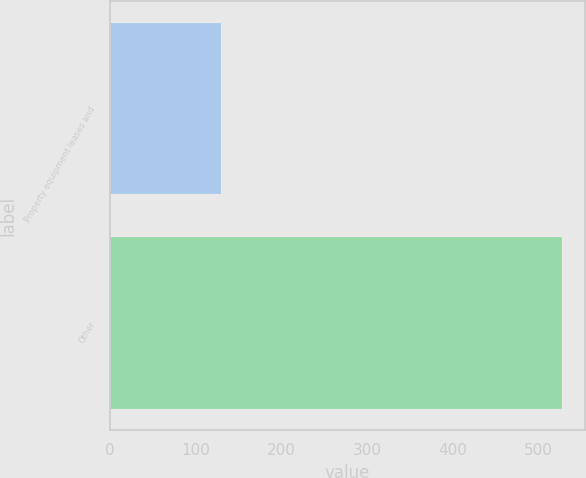<chart> <loc_0><loc_0><loc_500><loc_500><bar_chart><fcel>Property equipment leases and<fcel>Other<nl><fcel>129<fcel>528<nl></chart> 